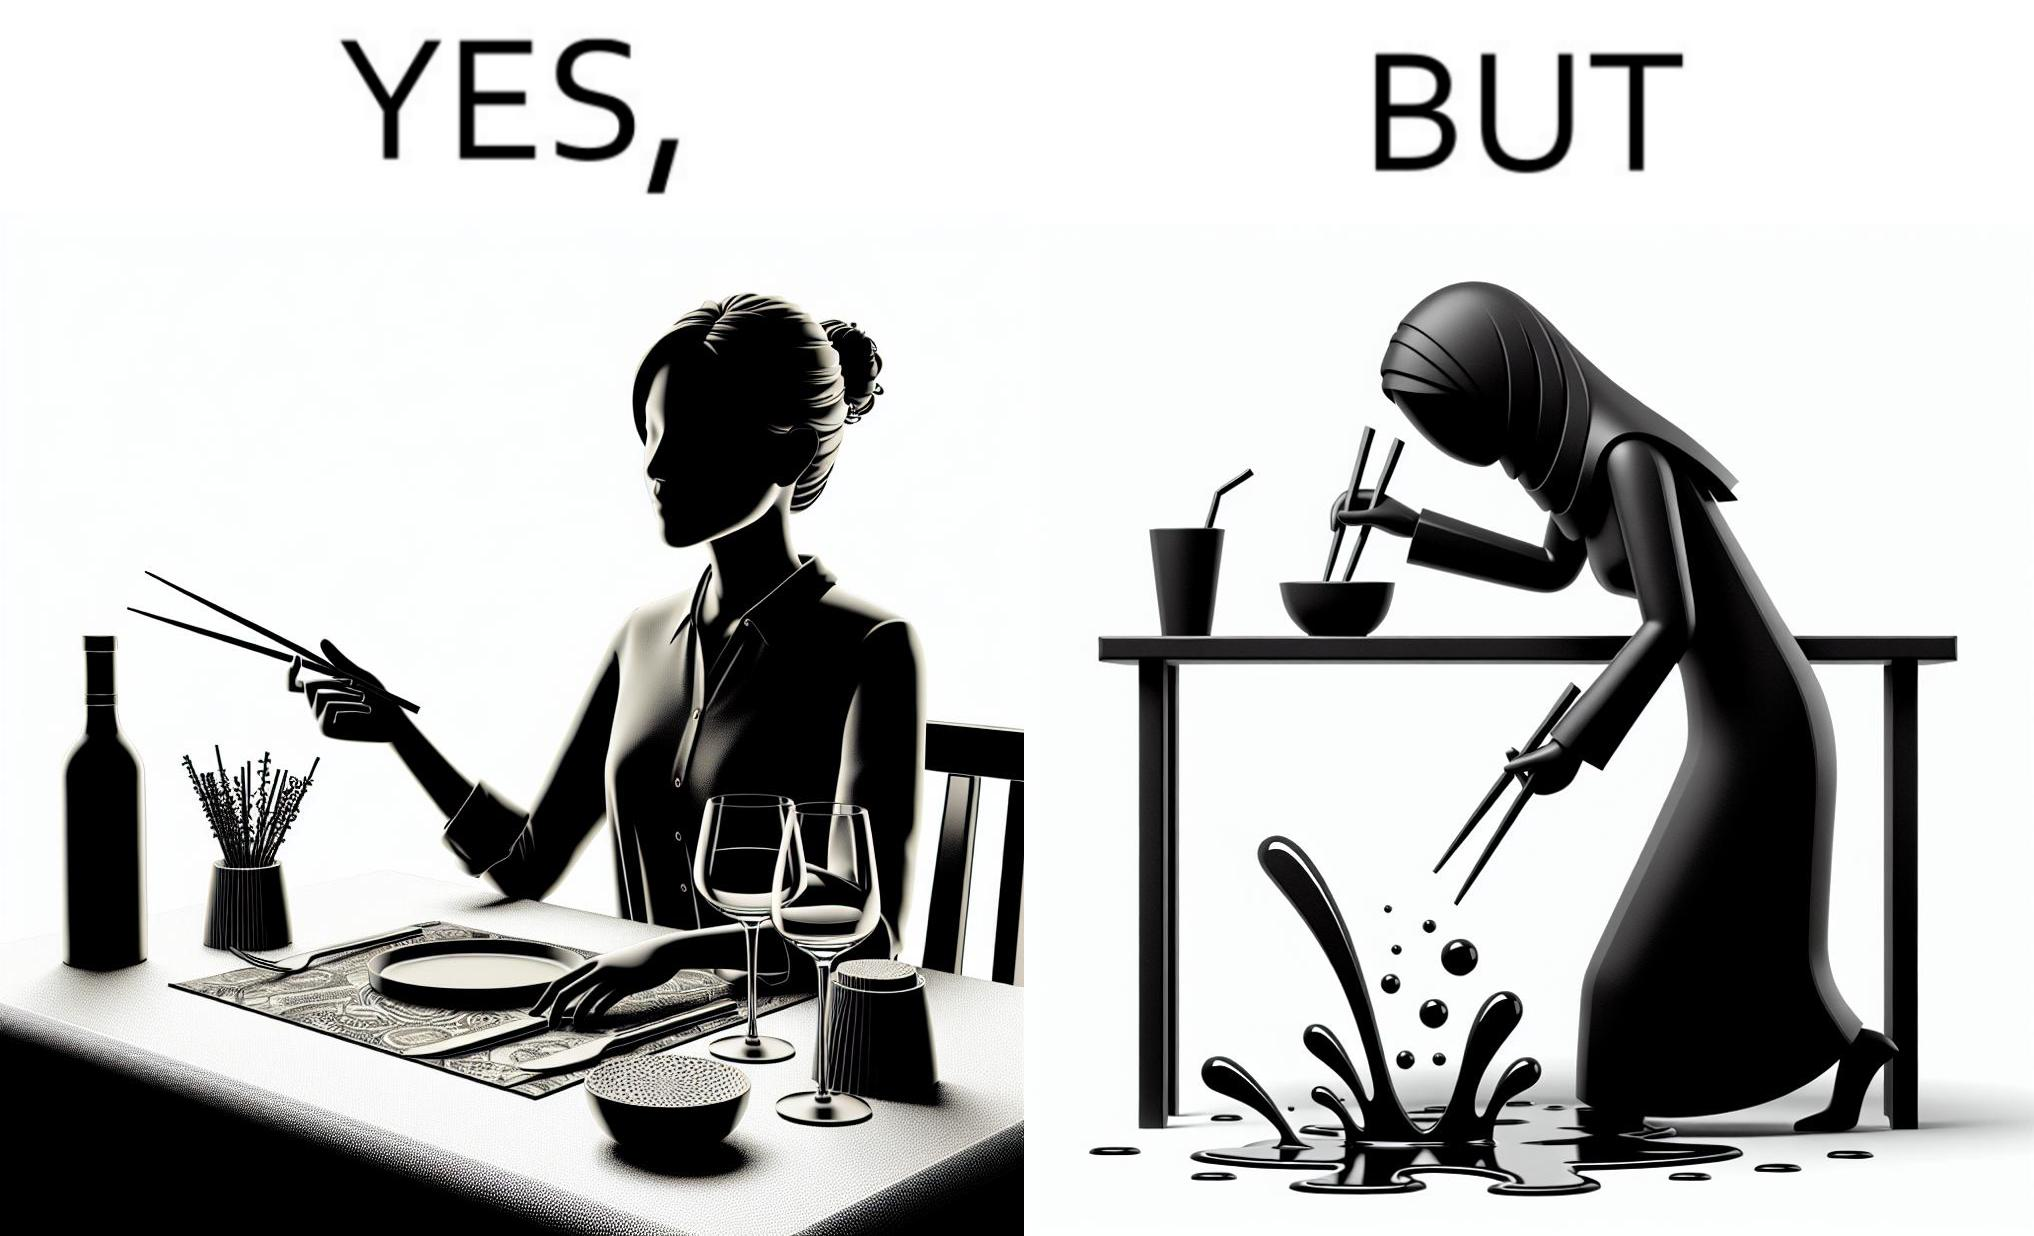Describe the satirical element in this image. The image is satirical because even thought the woman is not able to eat food with chopstick properly, she chooses it over fork and knife to look sophisticaed. 